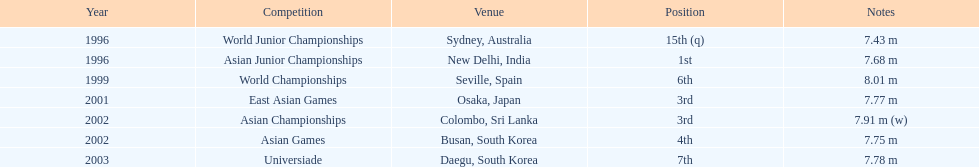Which year was his best jump? 1999. 